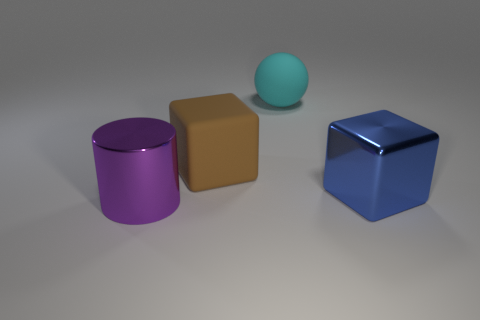How many other things are there of the same size as the cyan object?
Keep it short and to the point. 3. There is a big blue object that is the same shape as the brown rubber object; what is its material?
Offer a very short reply. Metal. What number of big objects are left of the cyan ball and to the right of the cyan thing?
Give a very brief answer. 0. There is a metal thing that is in front of the blue metal cube; does it have the same size as the shiny object that is behind the purple cylinder?
Your answer should be very brief. Yes. What number of things are either large cyan spheres to the right of the big brown block or small green cylinders?
Give a very brief answer. 1. What is the thing that is on the right side of the large cyan thing made of?
Give a very brief answer. Metal. What material is the large blue thing?
Offer a terse response. Metal. What is the material of the thing that is right of the large cyan object behind the block that is right of the cyan sphere?
Provide a succinct answer. Metal. There is a matte ball; is it the same size as the block to the right of the cyan sphere?
Offer a terse response. Yes. How many objects are either cubes behind the large blue block or large objects that are left of the blue block?
Your answer should be very brief. 3. 